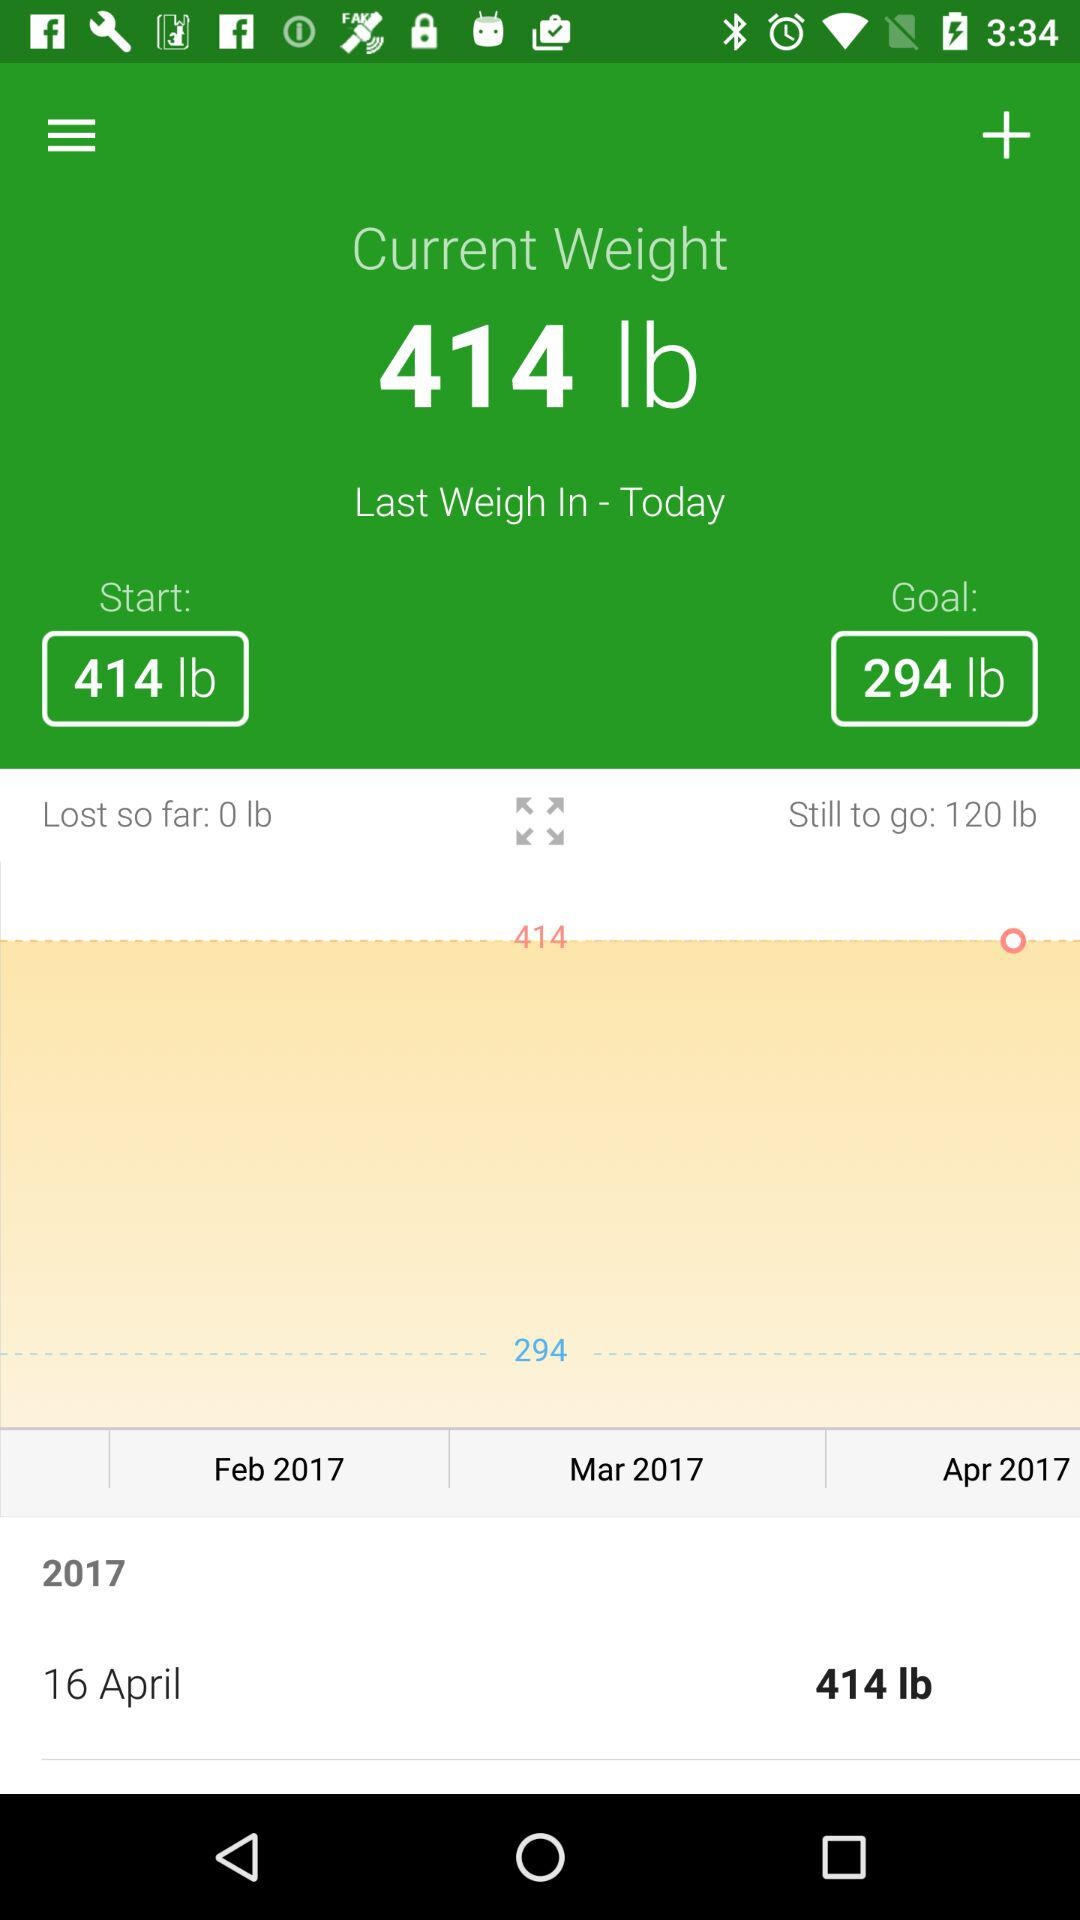How much more weight does the user need to lose to reach their goal?
Answer the question using a single word or phrase. 120 lb 